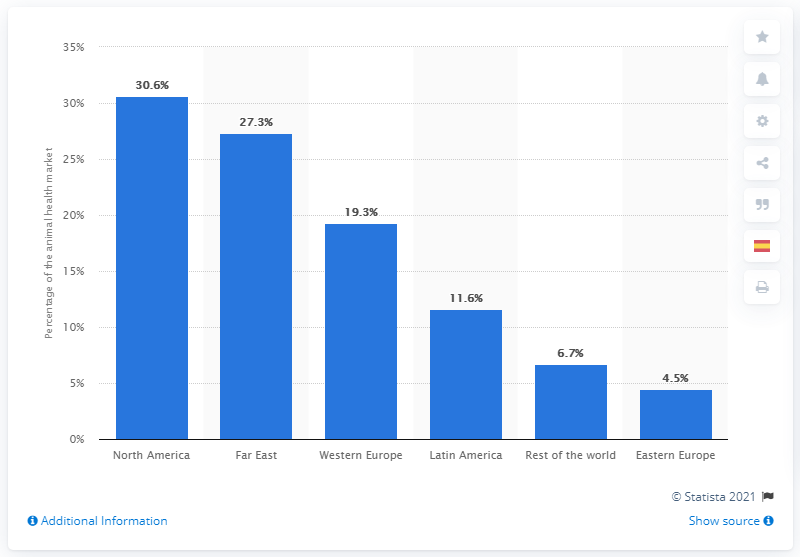Highlight a few significant elements in this photo. According to a report by Grand View Research, in 2017, North America held a significant portion of the total value of the animal health care market, accounting for 30.6% of the global market. According to the data, North America had the highest share of the global animal health care market value in 2017. 